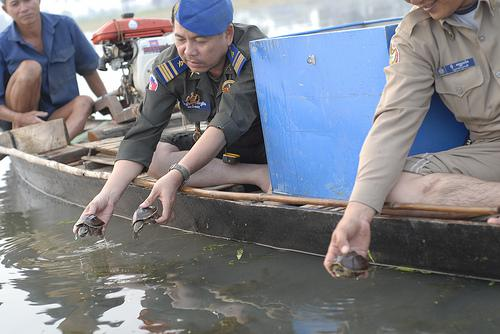Question: where are the people?
Choices:
A. In a boat.
B. On a plane.
C. On the beach.
D. In a car.
Answer with the letter. Answer: A Question: how many people are in the boat?
Choices:
A. Three.
B. Two.
C. Four.
D. Six.
Answer with the letter. Answer: A Question: what are two men doing?
Choices:
A. Feeding ducks.
B. Birdwatching.
C. Putting turtles in the water.
D. Walking dogs.
Answer with the letter. Answer: C Question: what does the middle man have on his head?
Choices:
A. A hat.
B. A beret.
C. A bandanna.
D. A straw hat.
Answer with the letter. Answer: B Question: what does the man in the middle have on his wrist?
Choices:
A. A rubberband.
B. A watch.
C. A bracelet.
D. A medical bracelet.
Answer with the letter. Answer: B Question: what kind of turtles are these?
Choices:
A. African sideneck turtles.
B. Baby turtles.
C. Musk turtles.
D. Painted turtles.
Answer with the letter. Answer: B 